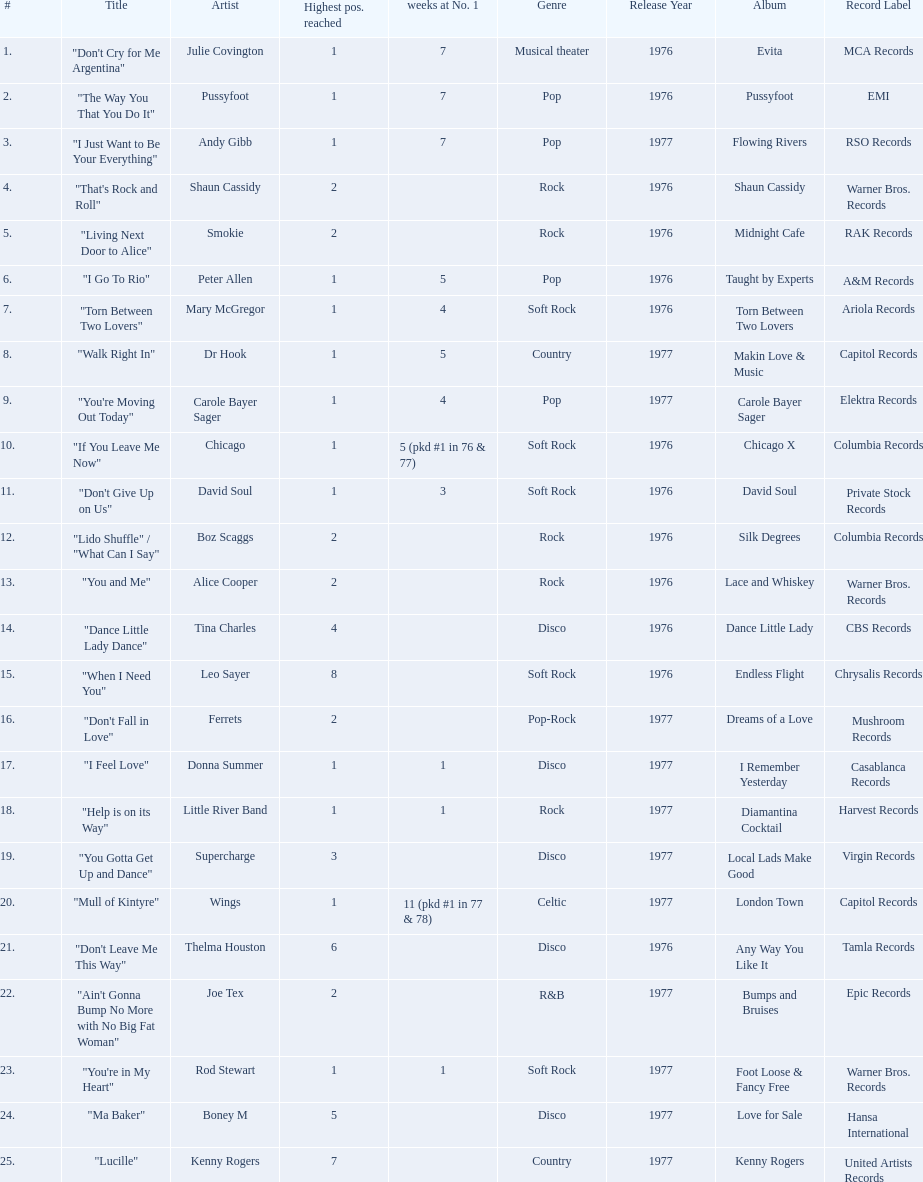How long is the longest amount of time spent at number 1? 11 (pkd #1 in 77 & 78). What song spent 11 weeks at number 1? "Mull of Kintyre". What band had a number 1 hit with this song? Wings. 